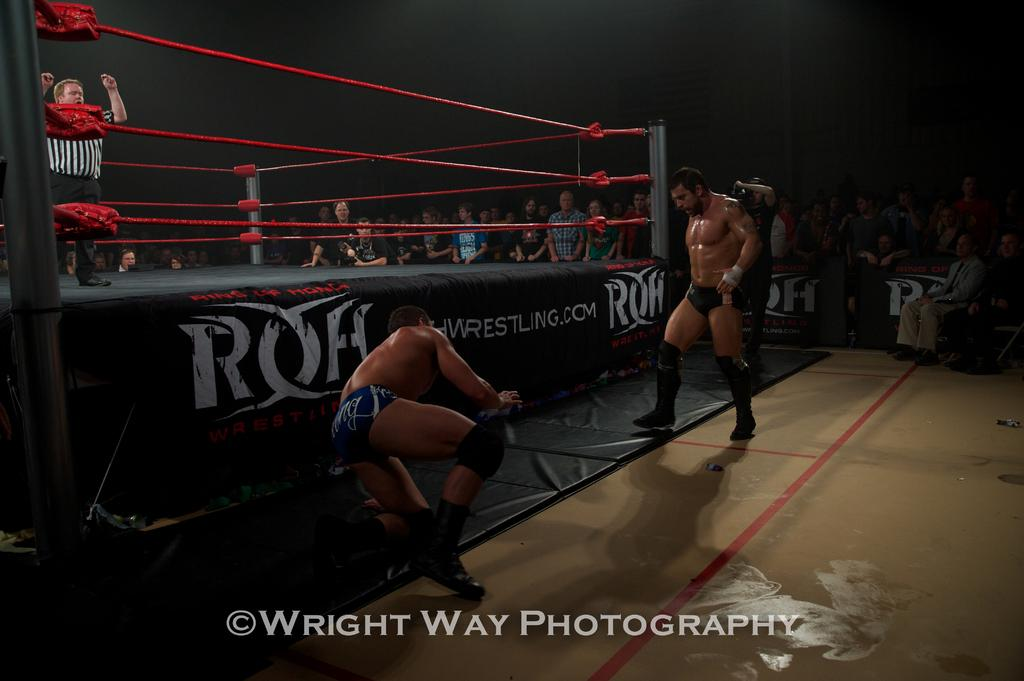<image>
Offer a succinct explanation of the picture presented. the name Wright is in the area under the man 